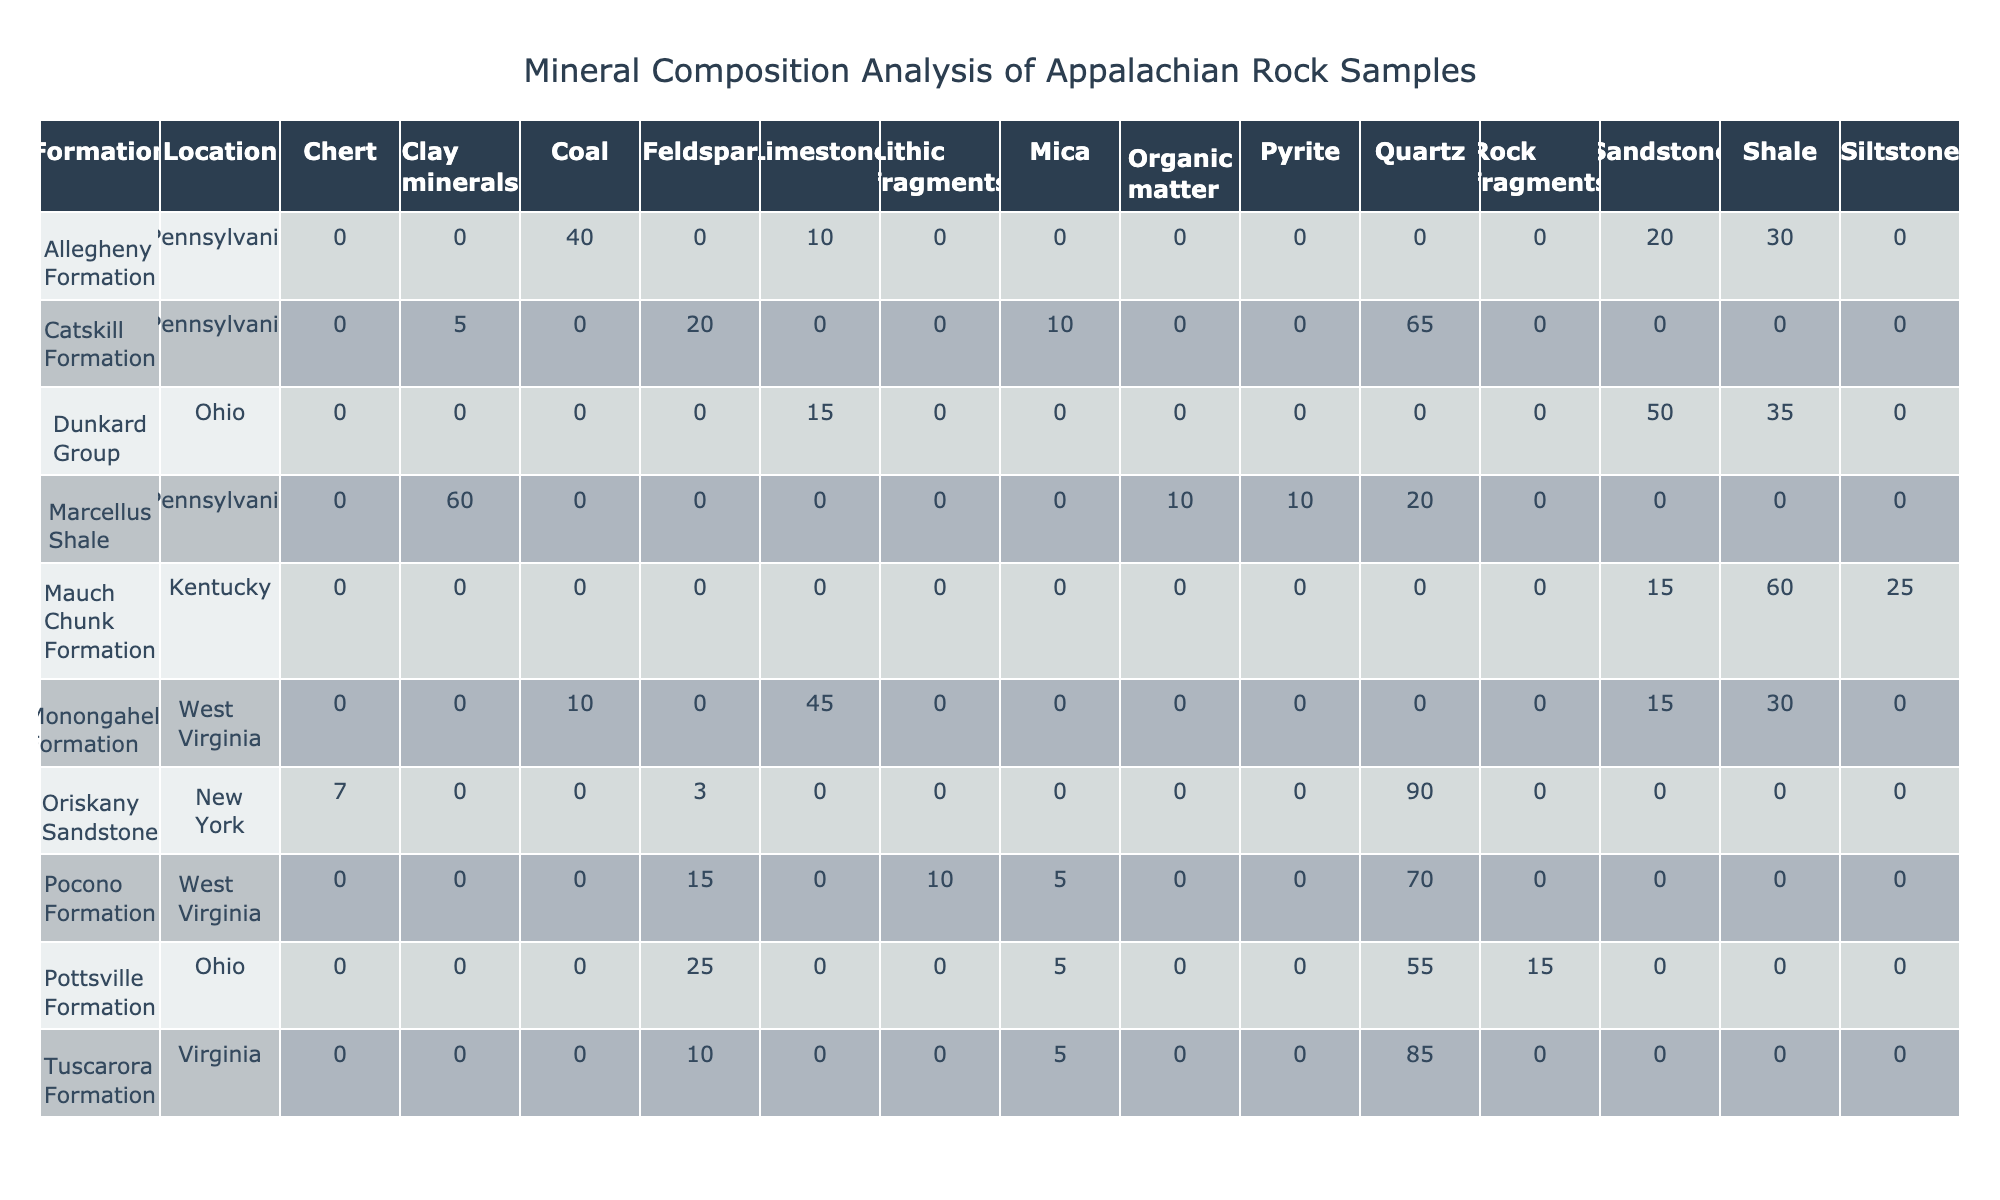What is the percentage of Quartz in the Oriskany Sandstone formation at New York? The table shows that in the Oriskany Sandstone formation located in New York, Quartz has a percentage of 90.
Answer: 90 Which formation has the highest percentage of Feldspar? By examining the table, the Catskill Formation in Pennsylvania has a Feldspar percentage of 20, while the Pocono Formation has 15, Pottsville Formation has 25, and Allegheny Formation has none. Therefore, Pottsville Formation has the highest at 25.
Answer: Pottsville Formation Is there any Limestone present in the Mauch Chunk Formation? The table lists the mineral compositions for the Mauch Chunk Formation and indicates that there is no presence of Limestone among the minerals, as Limestone is not listed for this formation.
Answer: No What is the total percentage of Clay minerals present in the samples listed? The only formation with Clay minerals is the Marcellus Shale in Pennsylvania, which has a percentage of 60. All other formations do not contribute to this sum. Therefore, the total is 60.
Answer: 60 Which formation has more total minerals, Pocono Formation or Monongahela Formation? For the Pocono Formation: Quartz (70) + Feldspar (15) + Lithic fragments (10) + Mica (5) = 100. For the Monongahela Formation: Limestone (45) + Shale (30) + Sandstone (15) + Coal (10) = 100. Thus, they have equal total percentages of minerals, which is 100 each.
Answer: Equal Which formation has the lowest depth among the samples listed? By analyzing the Depth (m) column in the table, the lowest depth is 170 m, found in both the Dunkard Group and the sample AP005 from the Allegheny Formation.
Answer: 170 Are there any samples with more than 50% of Mica? By checking the table's Mica percentages, the maximum observed is 35% in the Dunkard Group, while all other formations have less than 35%. Therefore, no sample exceeds 50% for Mica.
Answer: No What is the average percentage of Sandstone in the samples? Adding Sandstone percentages: Mauch Chunk (15) + Pottsville (15) + Allegheny (20) + Monongahela (15) + Dunkard (50) = 115. There are 5 samples, so the average percentage is 115 / 5 = 23.
Answer: 23 What percentage of total minerals consists of Quartz across all formations? By summing the Quartz percentages from each formation: 65 (Catskill) + 70 (Pocono) + 0 (Mauch Chunk) + 55 (Pottsville) + 0 (Allegheny) + 45 (Monongahela) + 0 (Dunkard) + 85 (Tuscarora) + 90 (Oriskany) + 20 (Marcellus) = 430. The total minerals sum = 1000. Thus, (430 / 1000) * 100 = 43%.
Answer: 43% 